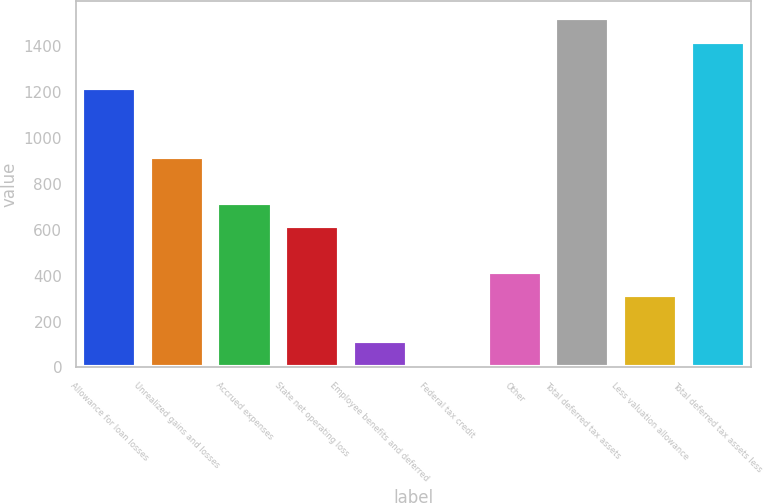Convert chart to OTSL. <chart><loc_0><loc_0><loc_500><loc_500><bar_chart><fcel>Allowance for loan losses<fcel>Unrealized gains and losses<fcel>Accrued expenses<fcel>State net operating loss<fcel>Employee benefits and deferred<fcel>Federal tax credit<fcel>Other<fcel>Total deferred tax assets<fcel>Less valuation allowance<fcel>Total deferred tax assets less<nl><fcel>1220.2<fcel>918.4<fcel>717.2<fcel>616.6<fcel>113.6<fcel>13<fcel>415.4<fcel>1522<fcel>314.8<fcel>1421.4<nl></chart> 